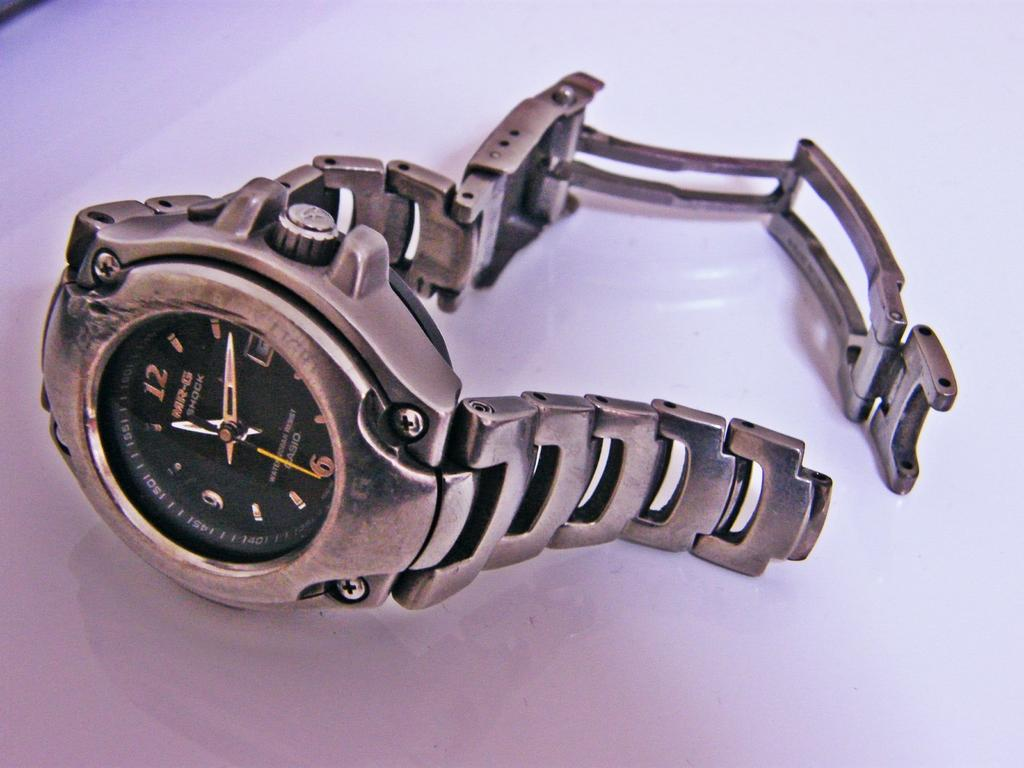<image>
Present a compact description of the photo's key features. A broken Casio MR-G Shock watch is laying on the counter. 